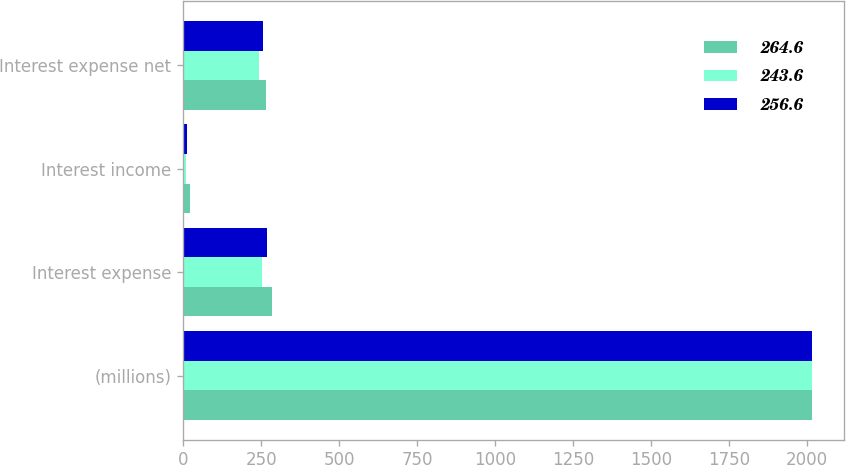Convert chart to OTSL. <chart><loc_0><loc_0><loc_500><loc_500><stacked_bar_chart><ecel><fcel>(millions)<fcel>Interest expense<fcel>Interest income<fcel>Interest expense net<nl><fcel>264.6<fcel>2016<fcel>285.4<fcel>20.8<fcel>264.6<nl><fcel>243.6<fcel>2015<fcel>253.7<fcel>10.1<fcel>243.6<nl><fcel>256.6<fcel>2014<fcel>268<fcel>11.4<fcel>256.6<nl></chart> 